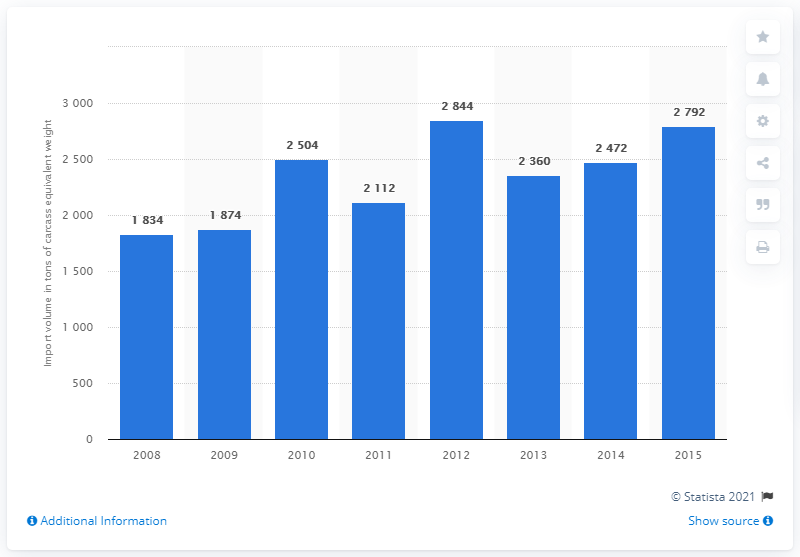Point out several critical features in this image. In 2012, the import volume of rabbit meat reached its highest point. 